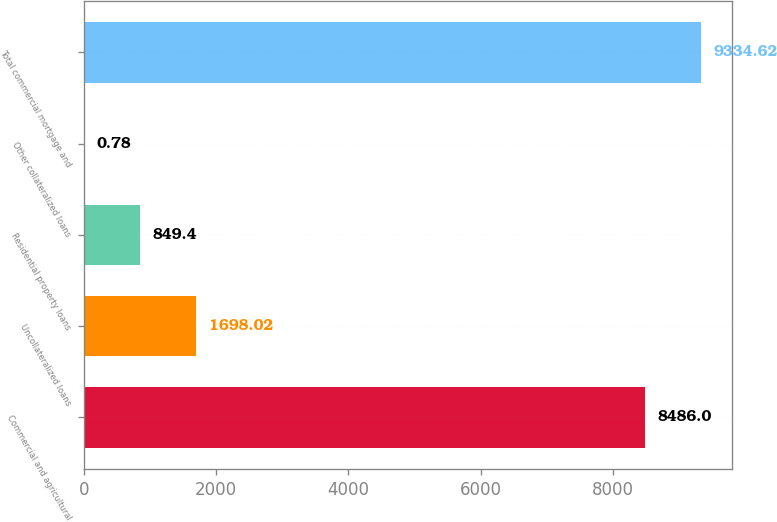Convert chart. <chart><loc_0><loc_0><loc_500><loc_500><bar_chart><fcel>Commercial and agricultural<fcel>Uncollateralized loans<fcel>Residential property loans<fcel>Other collateralized loans<fcel>Total commercial mortgage and<nl><fcel>8486<fcel>1698.02<fcel>849.4<fcel>0.78<fcel>9334.62<nl></chart> 